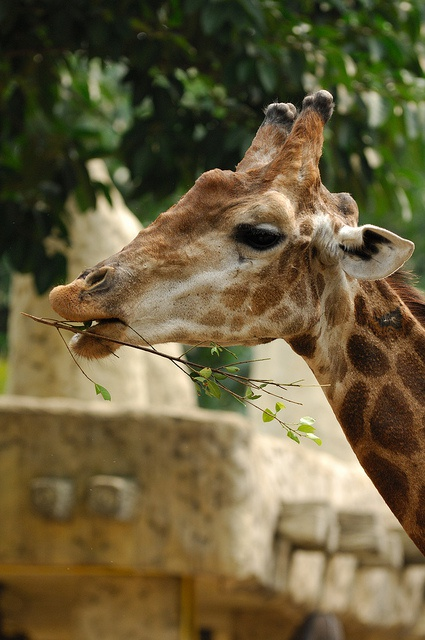Describe the objects in this image and their specific colors. I can see a giraffe in black, maroon, and gray tones in this image. 